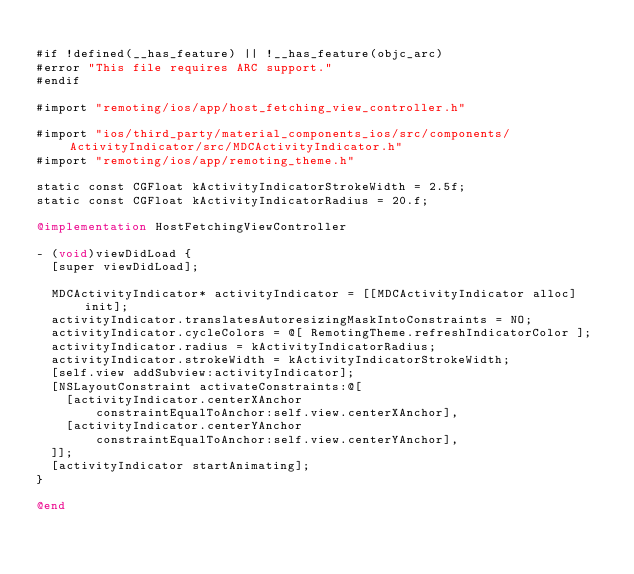Convert code to text. <code><loc_0><loc_0><loc_500><loc_500><_ObjectiveC_>
#if !defined(__has_feature) || !__has_feature(objc_arc)
#error "This file requires ARC support."
#endif

#import "remoting/ios/app/host_fetching_view_controller.h"

#import "ios/third_party/material_components_ios/src/components/ActivityIndicator/src/MDCActivityIndicator.h"
#import "remoting/ios/app/remoting_theme.h"

static const CGFloat kActivityIndicatorStrokeWidth = 2.5f;
static const CGFloat kActivityIndicatorRadius = 20.f;

@implementation HostFetchingViewController

- (void)viewDidLoad {
  [super viewDidLoad];

  MDCActivityIndicator* activityIndicator = [[MDCActivityIndicator alloc] init];
  activityIndicator.translatesAutoresizingMaskIntoConstraints = NO;
  activityIndicator.cycleColors = @[ RemotingTheme.refreshIndicatorColor ];
  activityIndicator.radius = kActivityIndicatorRadius;
  activityIndicator.strokeWidth = kActivityIndicatorStrokeWidth;
  [self.view addSubview:activityIndicator];
  [NSLayoutConstraint activateConstraints:@[
    [activityIndicator.centerXAnchor
        constraintEqualToAnchor:self.view.centerXAnchor],
    [activityIndicator.centerYAnchor
        constraintEqualToAnchor:self.view.centerYAnchor],
  ]];
  [activityIndicator startAnimating];
}

@end
</code> 